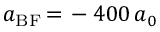<formula> <loc_0><loc_0><loc_500><loc_500>a _ { B F } \, { = } \, - 4 0 0 \, a _ { 0 }</formula> 